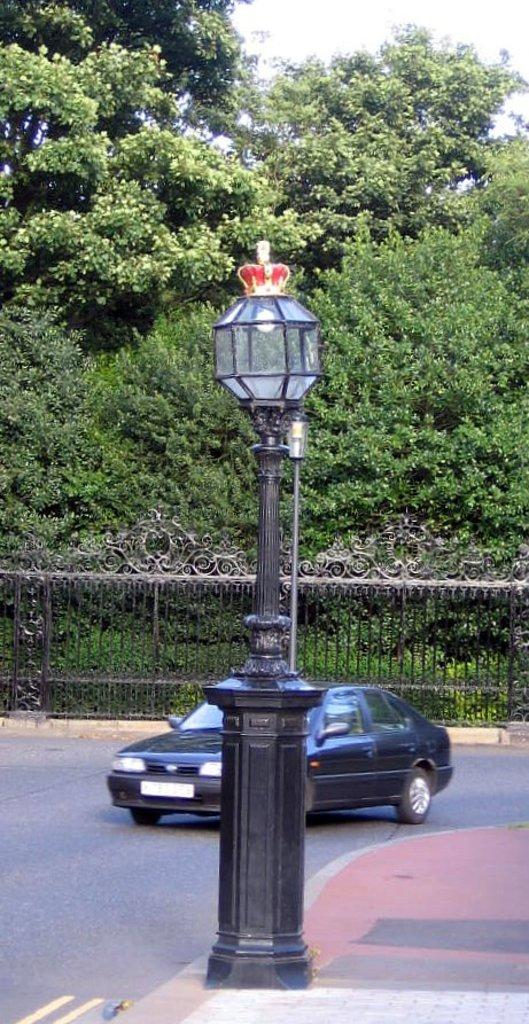What is the main feature of the image? There is a road in the image. What type of vehicle can be seen on the road? There is a black color car on the road. What structures are present alongside the road? There are poles and an iron gate in the image. What type of illumination is visible in the image? There are lights in the image. What type of vegetation is present in the image? There are trees in the image. What shape is the bed in the image? There is no bed present in the image. What type of board can be seen in the image? There is no board present in the image. 